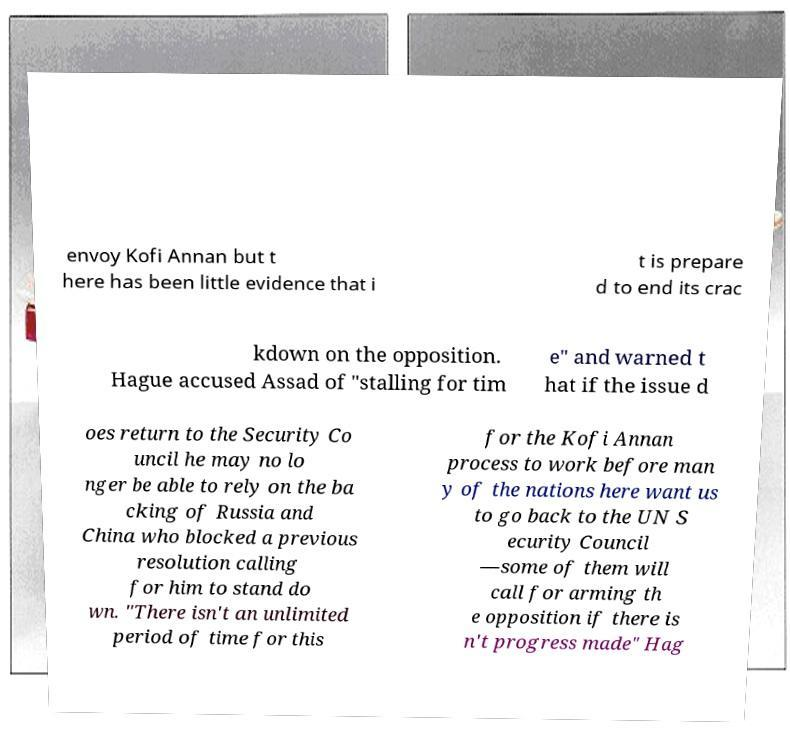There's text embedded in this image that I need extracted. Can you transcribe it verbatim? envoy Kofi Annan but t here has been little evidence that i t is prepare d to end its crac kdown on the opposition. Hague accused Assad of "stalling for tim e" and warned t hat if the issue d oes return to the Security Co uncil he may no lo nger be able to rely on the ba cking of Russia and China who blocked a previous resolution calling for him to stand do wn. "There isn't an unlimited period of time for this for the Kofi Annan process to work before man y of the nations here want us to go back to the UN S ecurity Council —some of them will call for arming th e opposition if there is n't progress made" Hag 